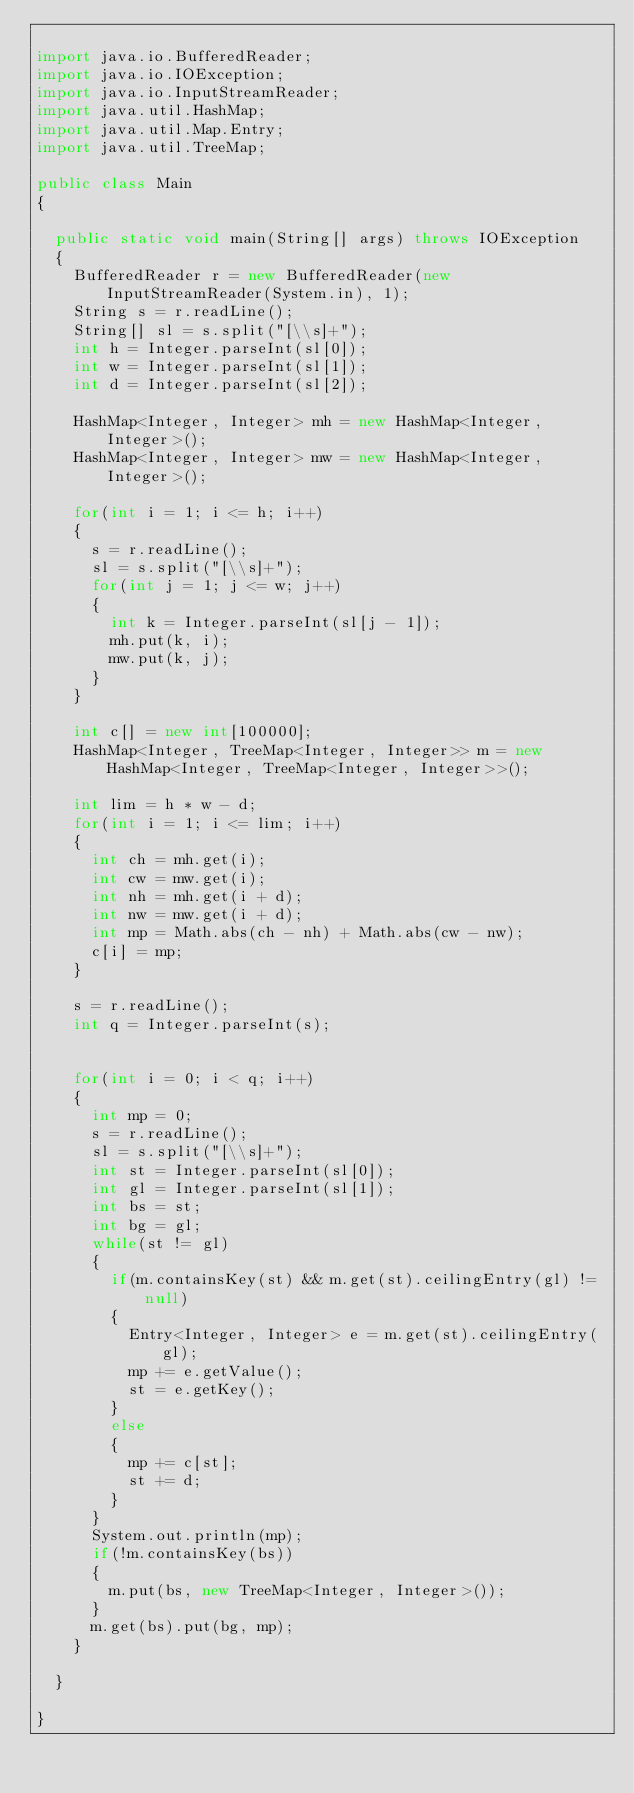Convert code to text. <code><loc_0><loc_0><loc_500><loc_500><_Java_>
import java.io.BufferedReader;
import java.io.IOException;
import java.io.InputStreamReader;
import java.util.HashMap;
import java.util.Map.Entry;
import java.util.TreeMap;

public class Main
{

  public static void main(String[] args) throws IOException
  {
    BufferedReader r = new BufferedReader(new InputStreamReader(System.in), 1);
    String s = r.readLine();
    String[] sl = s.split("[\\s]+");
    int h = Integer.parseInt(sl[0]);
    int w = Integer.parseInt(sl[1]);
    int d = Integer.parseInt(sl[2]);

    HashMap<Integer, Integer> mh = new HashMap<Integer, Integer>();
    HashMap<Integer, Integer> mw = new HashMap<Integer, Integer>();

    for(int i = 1; i <= h; i++)
    {
      s = r.readLine();
      sl = s.split("[\\s]+");
      for(int j = 1; j <= w; j++)
      {
        int k = Integer.parseInt(sl[j - 1]);
        mh.put(k, i);
        mw.put(k, j);
      }
    }

    int c[] = new int[100000];
    HashMap<Integer, TreeMap<Integer, Integer>> m = new HashMap<Integer, TreeMap<Integer, Integer>>();

    int lim = h * w - d;
    for(int i = 1; i <= lim; i++)
    {
      int ch = mh.get(i);
      int cw = mw.get(i);
      int nh = mh.get(i + d);
      int nw = mw.get(i + d);
      int mp = Math.abs(ch - nh) + Math.abs(cw - nw);
      c[i] = mp;
    }

    s = r.readLine();
    int q = Integer.parseInt(s);


    for(int i = 0; i < q; i++)
    {
      int mp = 0;
      s = r.readLine();
      sl = s.split("[\\s]+");
      int st = Integer.parseInt(sl[0]);
      int gl = Integer.parseInt(sl[1]);
      int bs = st;
      int bg = gl;
      while(st != gl)
      {
        if(m.containsKey(st) && m.get(st).ceilingEntry(gl) != null)
        {
          Entry<Integer, Integer> e = m.get(st).ceilingEntry(gl);
          mp += e.getValue();
          st = e.getKey();
        }
        else
        {
          mp += c[st];
          st += d;
        }
      }
      System.out.println(mp);
      if(!m.containsKey(bs))
      {
        m.put(bs, new TreeMap<Integer, Integer>());
      }
      m.get(bs).put(bg, mp);
    }

  }

}
</code> 